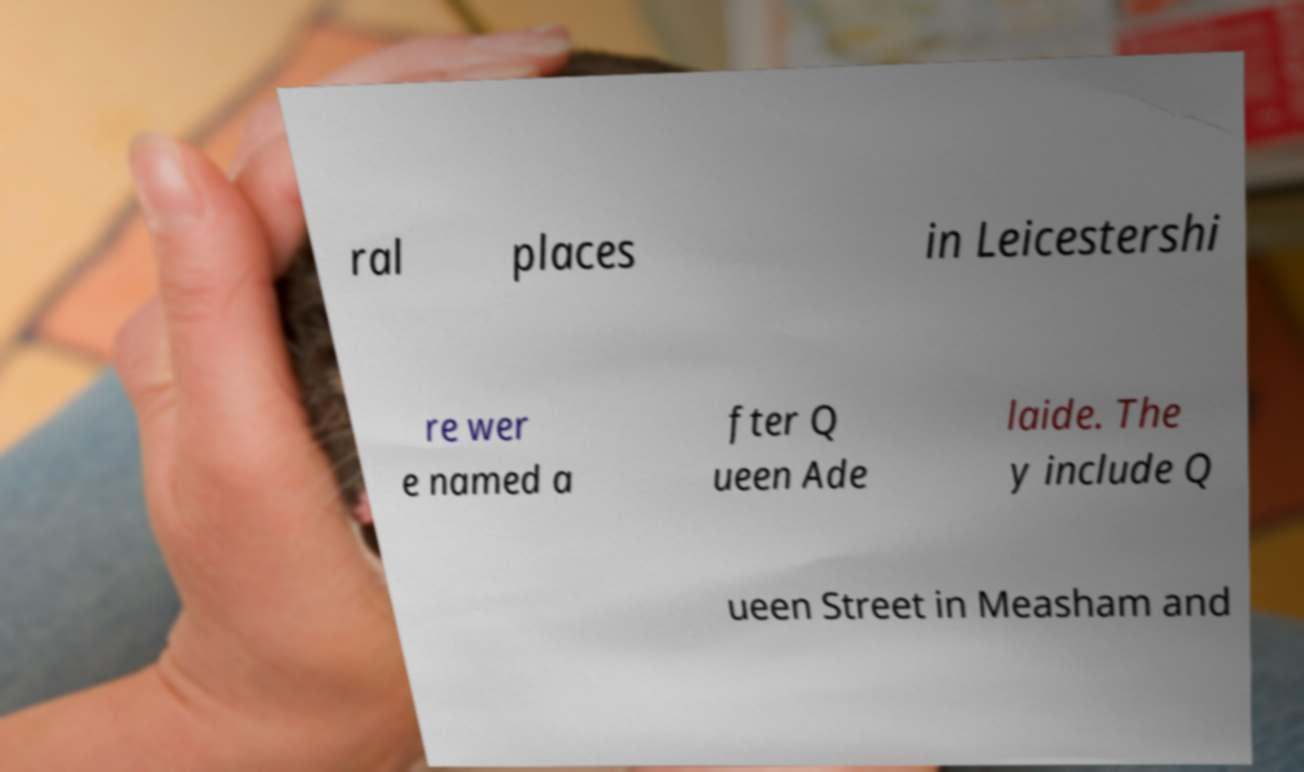Can you accurately transcribe the text from the provided image for me? ral places in Leicestershi re wer e named a fter Q ueen Ade laide. The y include Q ueen Street in Measham and 